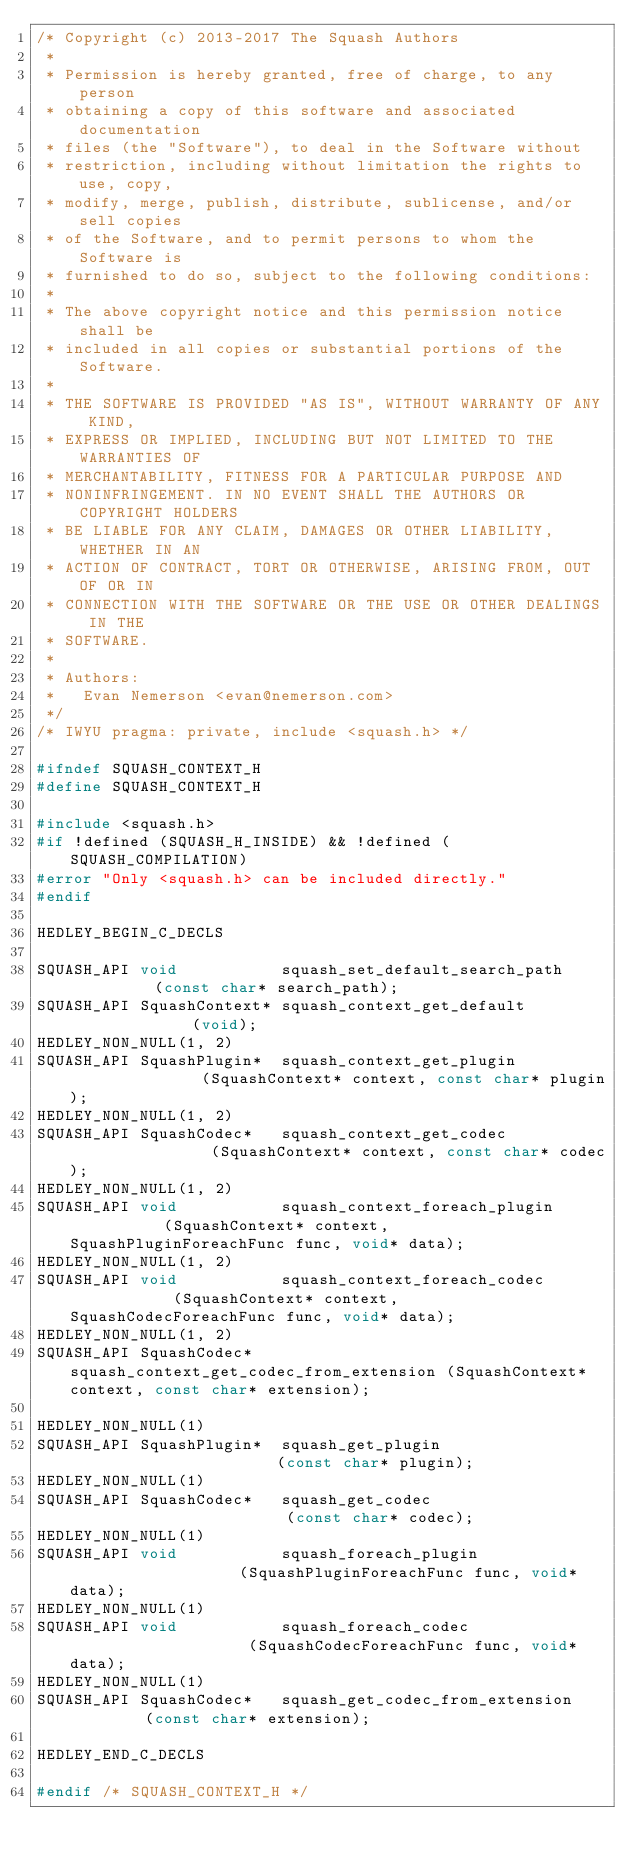Convert code to text. <code><loc_0><loc_0><loc_500><loc_500><_C_>/* Copyright (c) 2013-2017 The Squash Authors
 *
 * Permission is hereby granted, free of charge, to any person
 * obtaining a copy of this software and associated documentation
 * files (the "Software"), to deal in the Software without
 * restriction, including without limitation the rights to use, copy,
 * modify, merge, publish, distribute, sublicense, and/or sell copies
 * of the Software, and to permit persons to whom the Software is
 * furnished to do so, subject to the following conditions:
 *
 * The above copyright notice and this permission notice shall be
 * included in all copies or substantial portions of the Software.
 *
 * THE SOFTWARE IS PROVIDED "AS IS", WITHOUT WARRANTY OF ANY KIND,
 * EXPRESS OR IMPLIED, INCLUDING BUT NOT LIMITED TO THE WARRANTIES OF
 * MERCHANTABILITY, FITNESS FOR A PARTICULAR PURPOSE AND
 * NONINFRINGEMENT. IN NO EVENT SHALL THE AUTHORS OR COPYRIGHT HOLDERS
 * BE LIABLE FOR ANY CLAIM, DAMAGES OR OTHER LIABILITY, WHETHER IN AN
 * ACTION OF CONTRACT, TORT OR OTHERWISE, ARISING FROM, OUT OF OR IN
 * CONNECTION WITH THE SOFTWARE OR THE USE OR OTHER DEALINGS IN THE
 * SOFTWARE.
 *
 * Authors:
 *   Evan Nemerson <evan@nemerson.com>
 */
/* IWYU pragma: private, include <squash.h> */

#ifndef SQUASH_CONTEXT_H
#define SQUASH_CONTEXT_H

#include <squash.h>
#if !defined (SQUASH_H_INSIDE) && !defined (SQUASH_COMPILATION)
#error "Only <squash.h> can be included directly."
#endif

HEDLEY_BEGIN_C_DECLS

SQUASH_API void           squash_set_default_search_path          (const char* search_path);
SQUASH_API SquashContext* squash_context_get_default              (void);
HEDLEY_NON_NULL(1, 2)
SQUASH_API SquashPlugin*  squash_context_get_plugin               (SquashContext* context, const char* plugin);
HEDLEY_NON_NULL(1, 2)
SQUASH_API SquashCodec*   squash_context_get_codec                (SquashContext* context, const char* codec);
HEDLEY_NON_NULL(1, 2)
SQUASH_API void           squash_context_foreach_plugin           (SquashContext* context, SquashPluginForeachFunc func, void* data);
HEDLEY_NON_NULL(1, 2)
SQUASH_API void           squash_context_foreach_codec            (SquashContext* context, SquashCodecForeachFunc func, void* data);
HEDLEY_NON_NULL(1, 2)
SQUASH_API SquashCodec*   squash_context_get_codec_from_extension (SquashContext* context, const char* extension);

HEDLEY_NON_NULL(1)
SQUASH_API SquashPlugin*  squash_get_plugin                       (const char* plugin);
HEDLEY_NON_NULL(1)
SQUASH_API SquashCodec*   squash_get_codec                        (const char* codec);
HEDLEY_NON_NULL(1)
SQUASH_API void           squash_foreach_plugin                   (SquashPluginForeachFunc func, void* data);
HEDLEY_NON_NULL(1)
SQUASH_API void           squash_foreach_codec                    (SquashCodecForeachFunc func, void* data);
HEDLEY_NON_NULL(1)
SQUASH_API SquashCodec*   squash_get_codec_from_extension         (const char* extension);

HEDLEY_END_C_DECLS

#endif /* SQUASH_CONTEXT_H */
</code> 